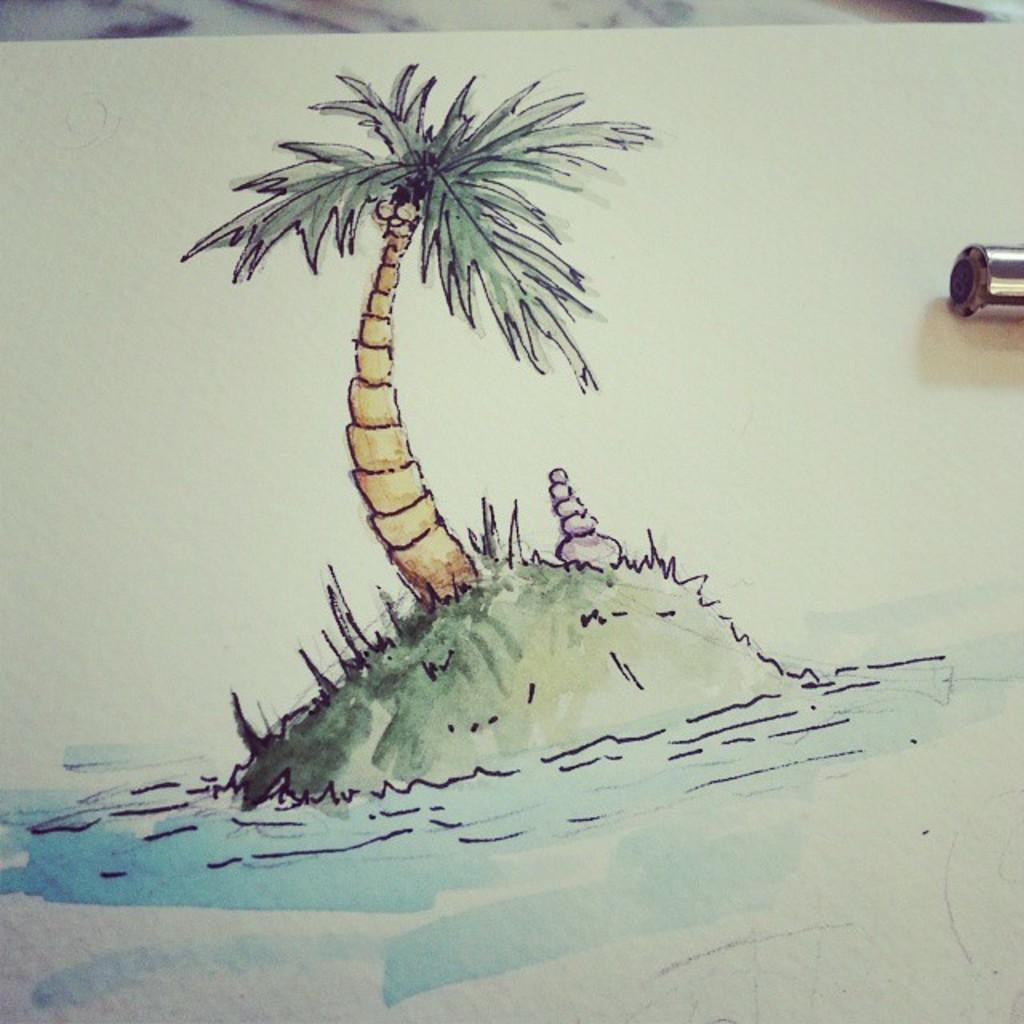What is the main subject of the image? The image contains an art piece. What is the central focus of the art piece? There is a painting of a tree in the middle of the art piece. What is depicted at the bottom of the art piece? There is water depicted at the bottom of the art piece. Where is the plantation located in the image? There is no plantation present in the image; it features a painting of a tree and water. What type of basket is used to collect the fruits from the tree in the image? There is no basket or fruit collection depicted in the image; it only shows a painting of a tree and water. 